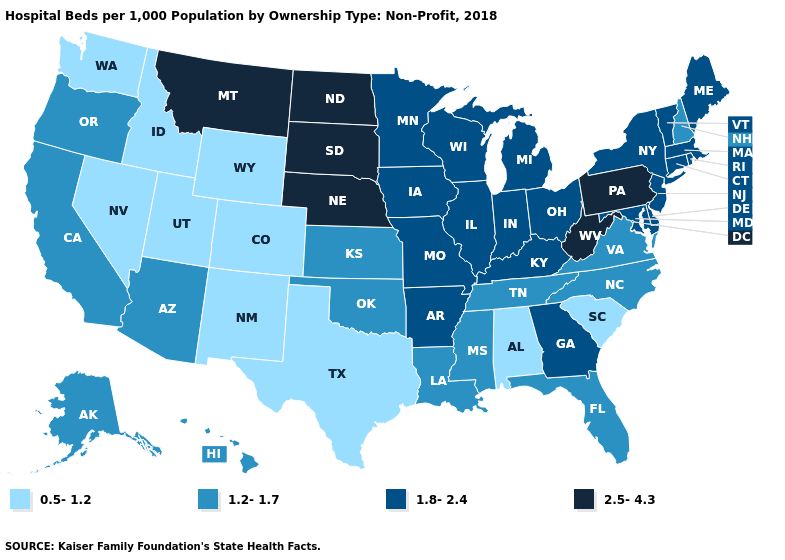What is the highest value in the South ?
Write a very short answer. 2.5-4.3. What is the highest value in the USA?
Be succinct. 2.5-4.3. What is the highest value in the MidWest ?
Write a very short answer. 2.5-4.3. Does Wyoming have the highest value in the USA?
Keep it brief. No. Does Hawaii have a lower value than Wisconsin?
Be succinct. Yes. Which states hav the highest value in the West?
Give a very brief answer. Montana. Name the states that have a value in the range 1.8-2.4?
Keep it brief. Arkansas, Connecticut, Delaware, Georgia, Illinois, Indiana, Iowa, Kentucky, Maine, Maryland, Massachusetts, Michigan, Minnesota, Missouri, New Jersey, New York, Ohio, Rhode Island, Vermont, Wisconsin. How many symbols are there in the legend?
Give a very brief answer. 4. Does Montana have the highest value in the USA?
Be succinct. Yes. What is the value of Mississippi?
Short answer required. 1.2-1.7. Name the states that have a value in the range 0.5-1.2?
Short answer required. Alabama, Colorado, Idaho, Nevada, New Mexico, South Carolina, Texas, Utah, Washington, Wyoming. Is the legend a continuous bar?
Write a very short answer. No. Which states have the highest value in the USA?
Short answer required. Montana, Nebraska, North Dakota, Pennsylvania, South Dakota, West Virginia. What is the lowest value in the Northeast?
Concise answer only. 1.2-1.7. Which states have the highest value in the USA?
Keep it brief. Montana, Nebraska, North Dakota, Pennsylvania, South Dakota, West Virginia. 